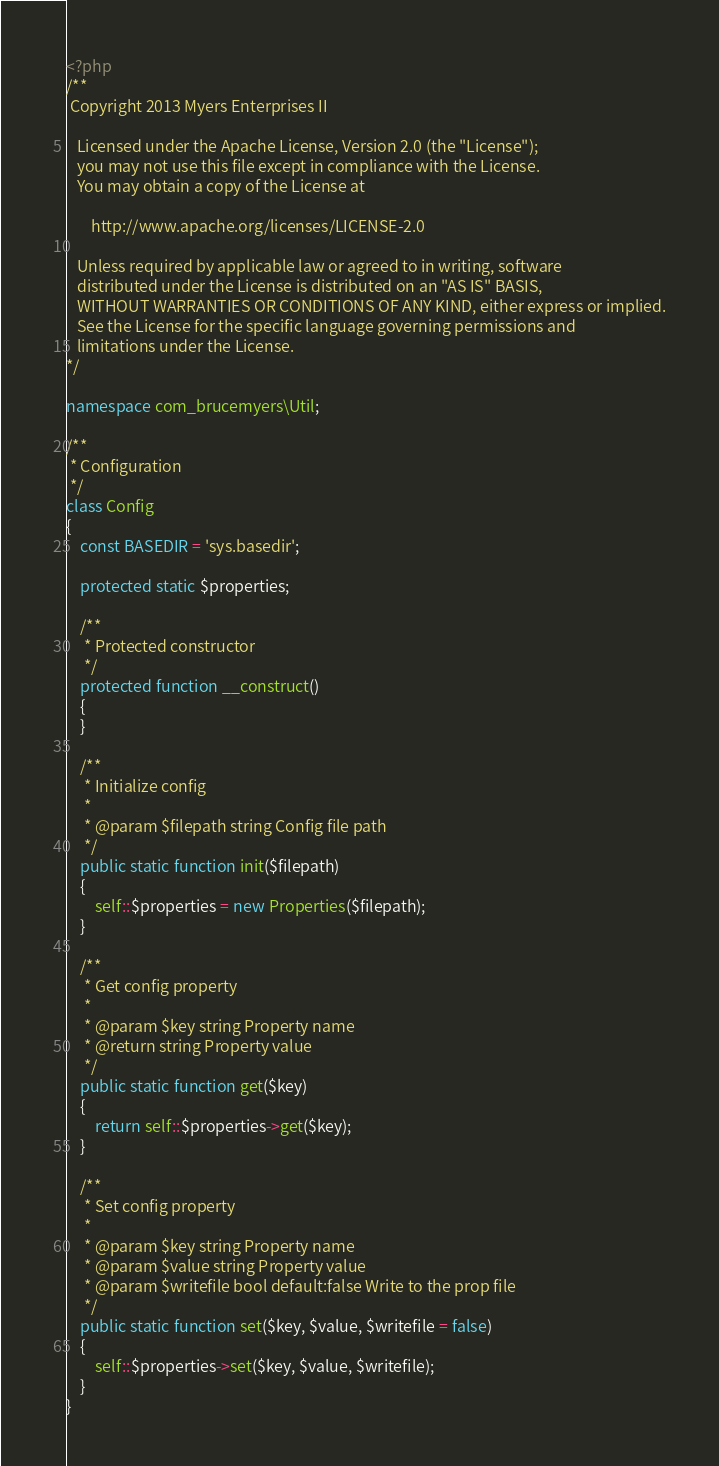Convert code to text. <code><loc_0><loc_0><loc_500><loc_500><_PHP_><?php
/**
 Copyright 2013 Myers Enterprises II

   Licensed under the Apache License, Version 2.0 (the "License");
   you may not use this file except in compliance with the License.
   You may obtain a copy of the License at

       http://www.apache.org/licenses/LICENSE-2.0

   Unless required by applicable law or agreed to in writing, software
   distributed under the License is distributed on an "AS IS" BASIS,
   WITHOUT WARRANTIES OR CONDITIONS OF ANY KIND, either express or implied.
   See the License for the specific language governing permissions and
   limitations under the License.
*/

namespace com_brucemyers\Util;

/**
 * Configuration
 */
class Config
{
    const BASEDIR = 'sys.basedir';

    protected static $properties;

    /**
     * Protected constructor
     */
    protected function __construct()
    {
    }

    /**
     * Initialize config
     *
     * @param $filepath string Config file path
     */
    public static function init($filepath)
    {
        self::$properties = new Properties($filepath);
    }

    /**
     * Get config property
     *
     * @param $key string Property name
     * @return string Property value
     */
    public static function get($key)
    {
        return self::$properties->get($key);
    }

    /**
     * Set config property
     *
     * @param $key string Property name
     * @param $value string Property value
     * @param $writefile bool default:false Write to the prop file
     */
    public static function set($key, $value, $writefile = false)
    {
        self::$properties->set($key, $value, $writefile);
    }
}</code> 